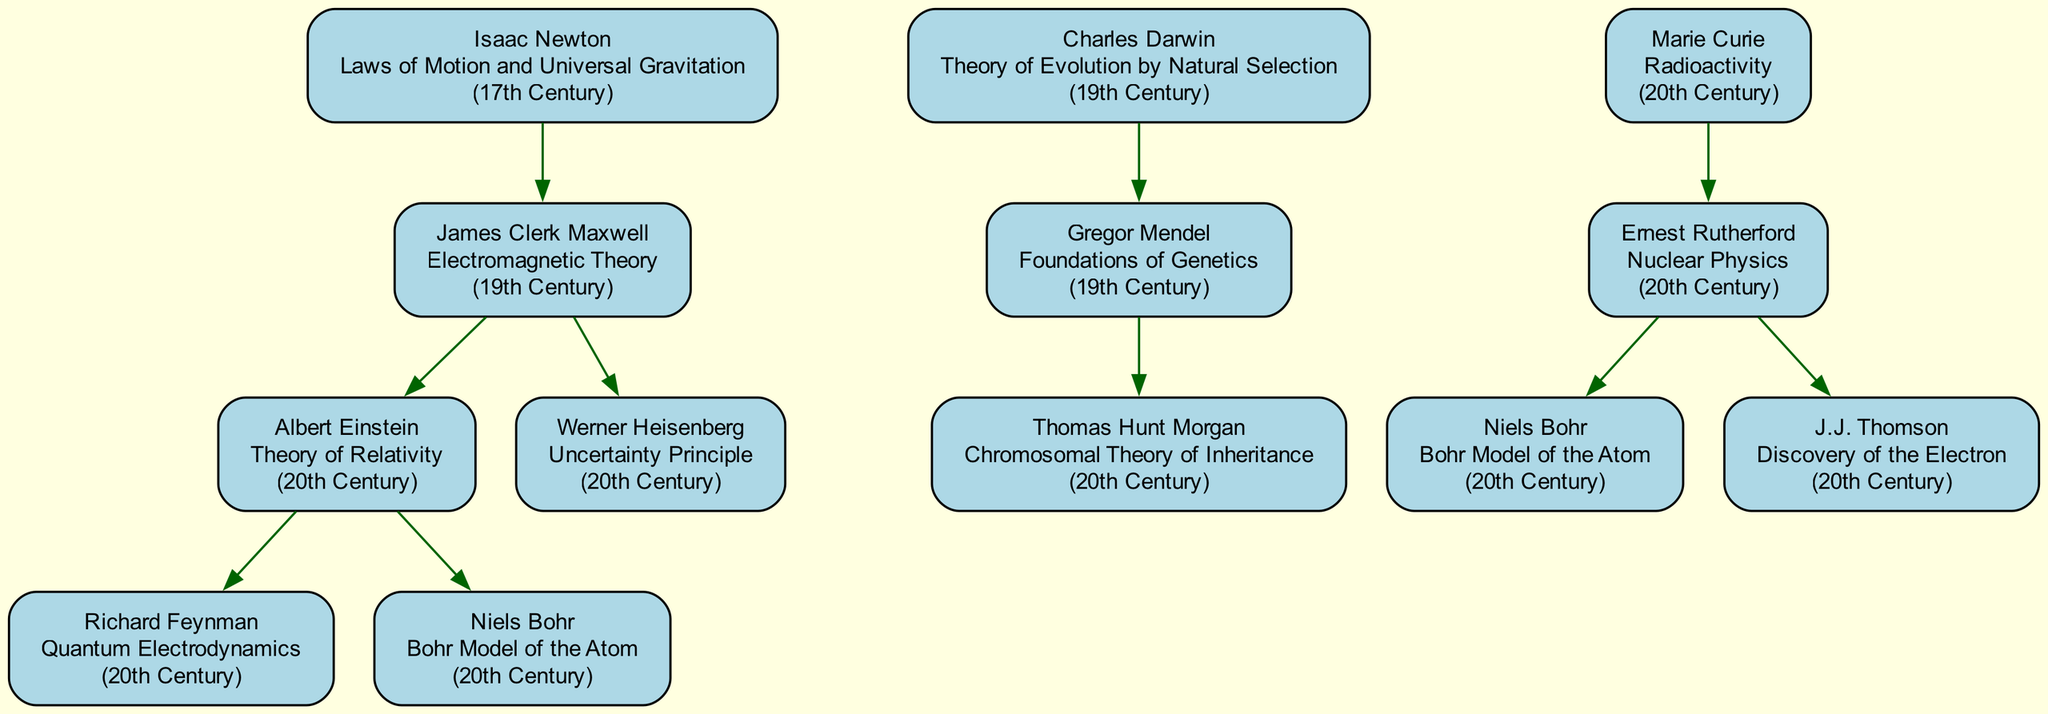What contribution did Isaac Newton make? According to the diagram, Isaac Newton's contribution is specified as "Laws of Motion and Universal Gravitation."
Answer: Laws of Motion and Universal Gravitation Who is the child of James Clerk Maxwell? Looking at the family tree, the child of James Clerk Maxwell is Albert Einstein.
Answer: Albert Einstein How many children does Marie Curie have? By examining the diagram, Marie Curie has one child, who is Ernest Rutherford.
Answer: 1 What era did Charles Darwin contribute in? The diagram clearly states that Charles Darwin's era is the "19th Century."
Answer: 19th Century Name one child of Albert Einstein. According to the family tree, one child of Albert Einstein is Richard Feynman.
Answer: Richard Feynman What is the relationship between Gregor Mendel and Charles Darwin? In the diagram, Gregor Mendel is a child of Charles Darwin, indicating a direct hierarchical relationship in the family tree.
Answer: Child Which discoverer's contribution is associated with Quantum Electrodynamics? The diagram indicates that Richard Feynman is associated with the contribution of Quantum Electrodynamics.
Answer: Richard Feynman What is the contribution of Niels Bohr? The family tree reveals that Niels Bohr's contribution is the "Bohr Model of the Atom."
Answer: Bohr Model of the Atom Who are the parents of Thomas Hunt Morgan? Through the family tree, it is evident that Thomas Hunt Morgan's parent is Gregor Mendel, and there's no indication of a second parent listed in this context.
Answer: Gregor Mendel How many total contributions are listed for the 20th Century? By inspecting the contributions in the family tree, there are four contributions listed for the 20th Century, as indicated by the individuals associated with that era.
Answer: 4 